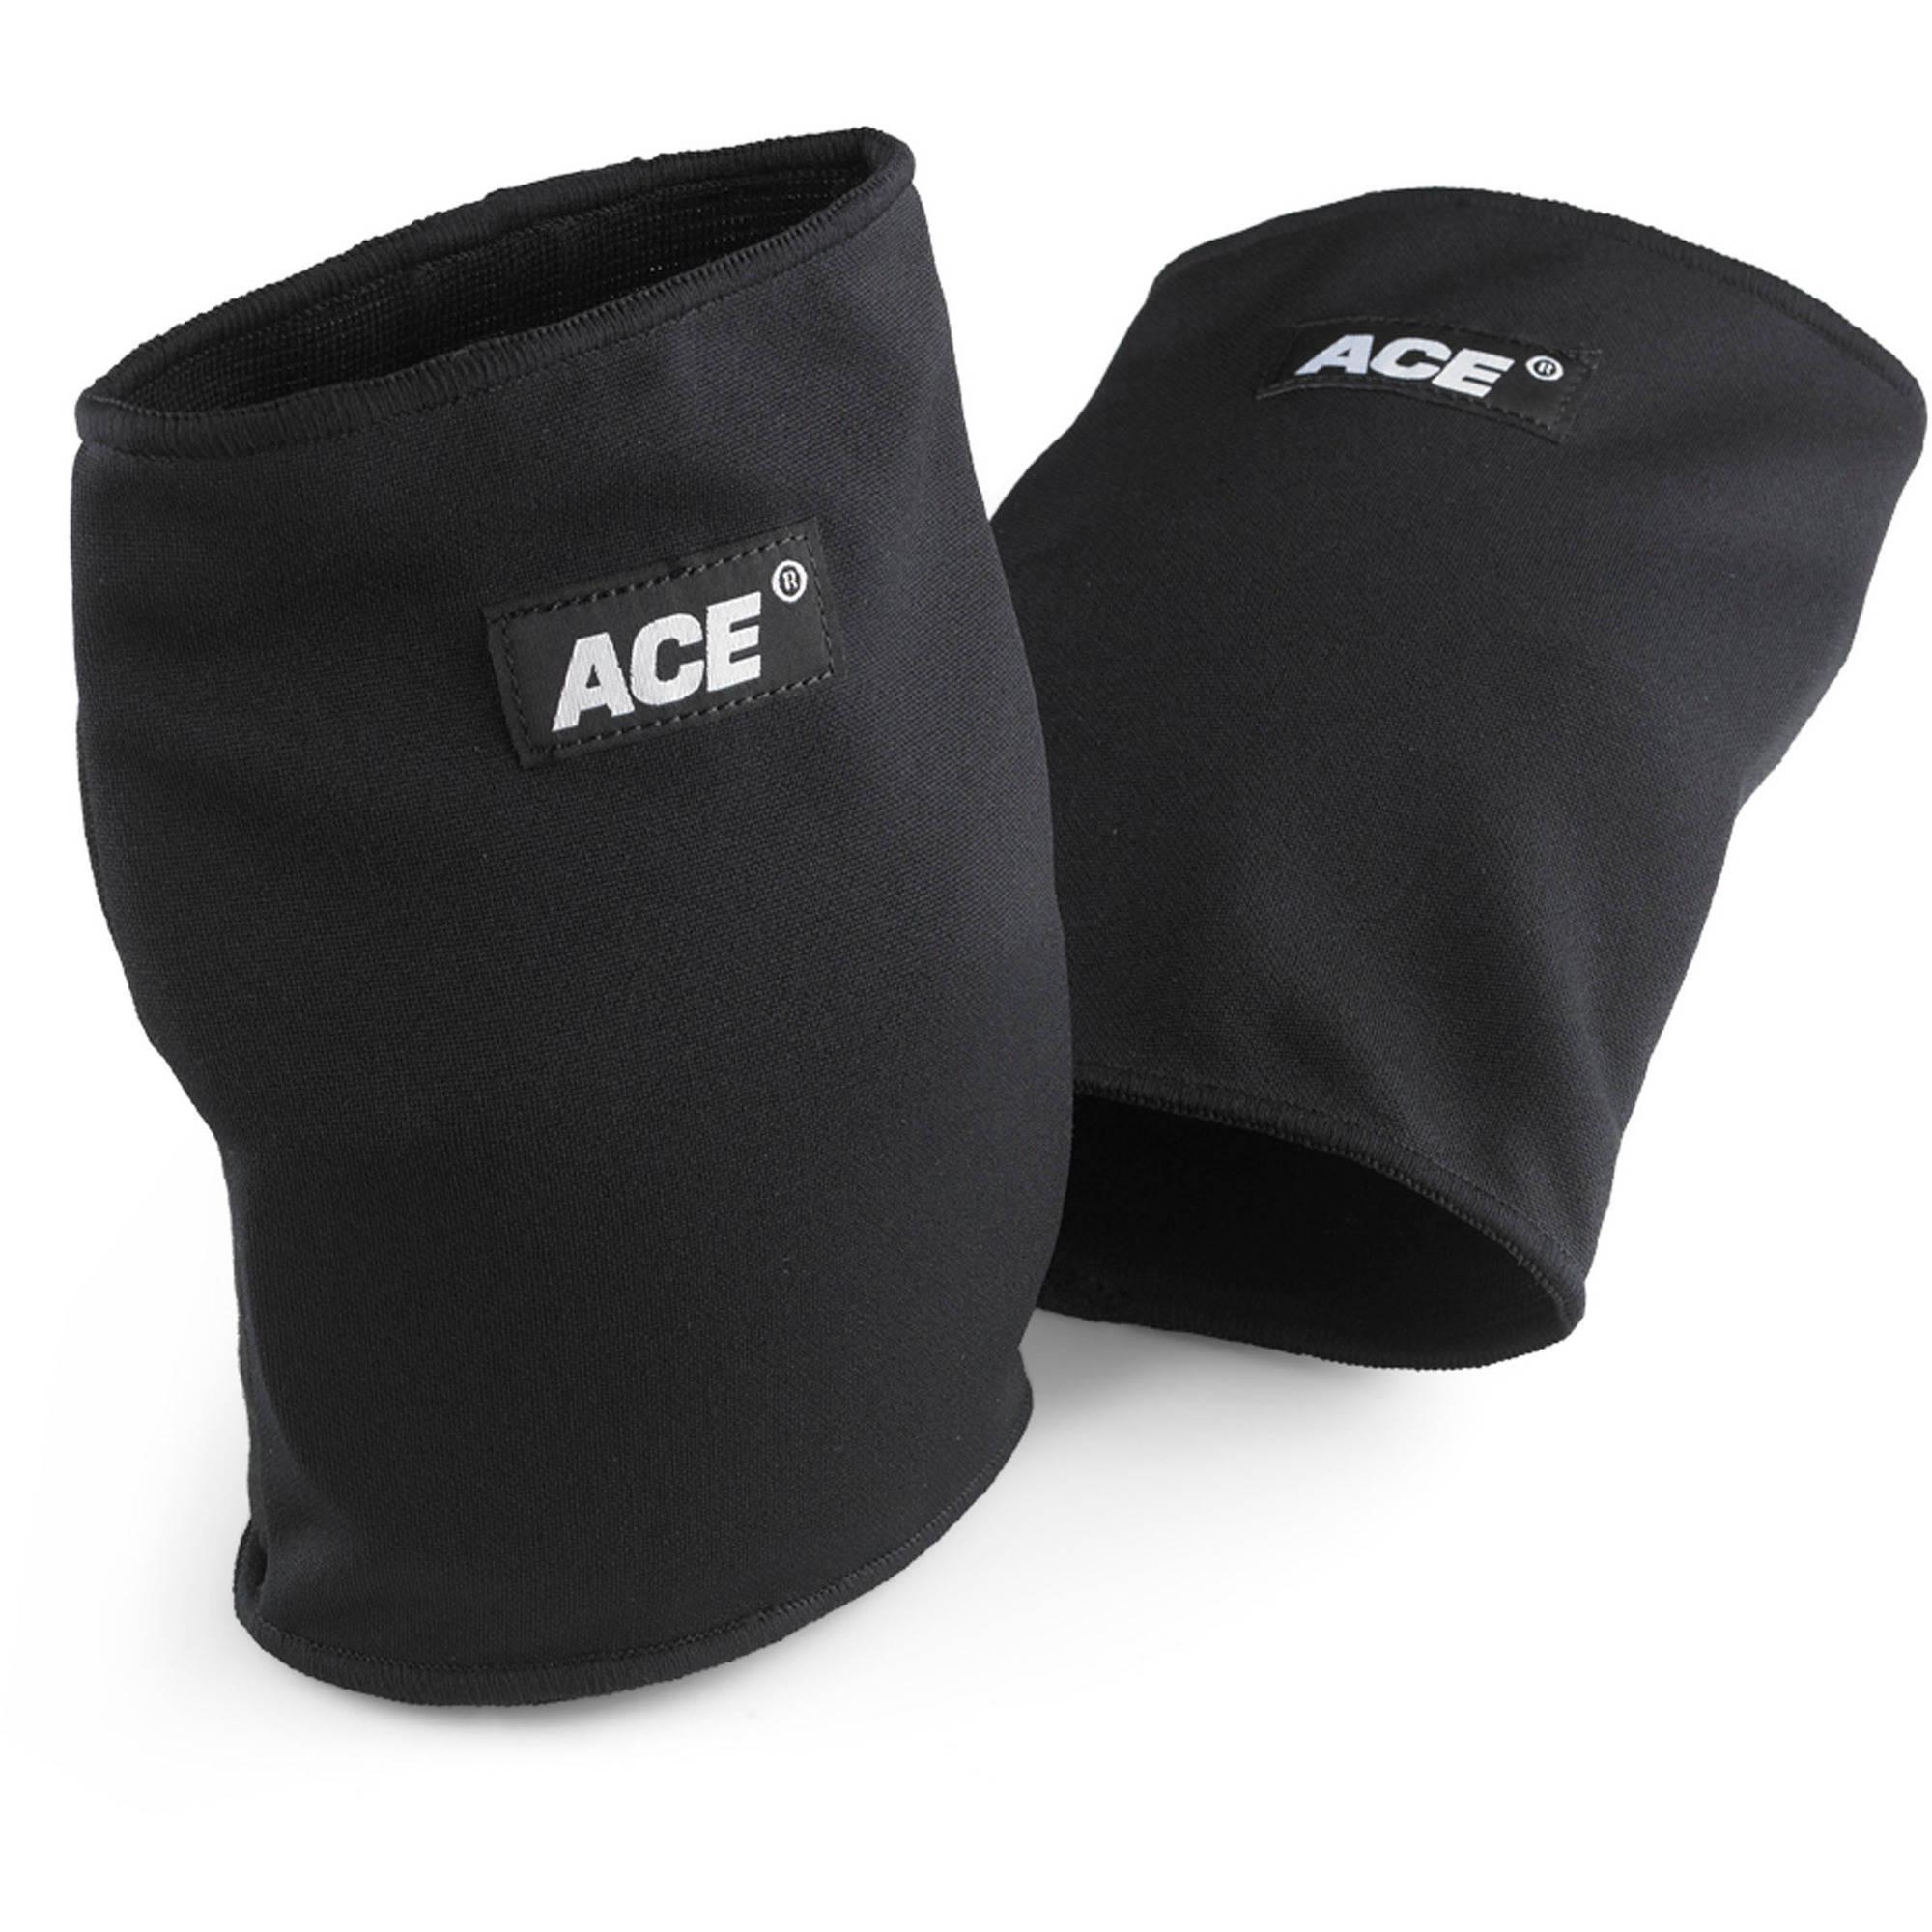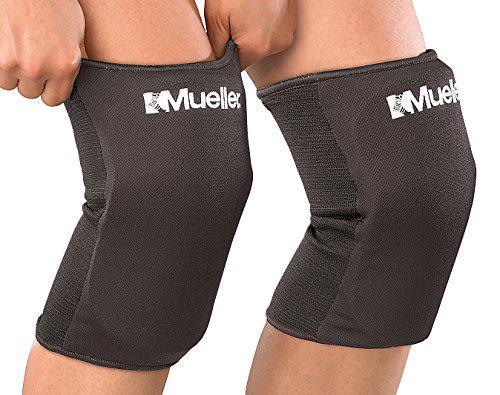The first image is the image on the left, the second image is the image on the right. For the images displayed, is the sentence "There are exactly two velcro closures in the image on the left." factually correct? Answer yes or no. No. The first image is the image on the left, the second image is the image on the right. Examine the images to the left and right. Is the description "Left image features one pair of all-black knee pads with three eyelet rivets per side." accurate? Answer yes or no. No. 